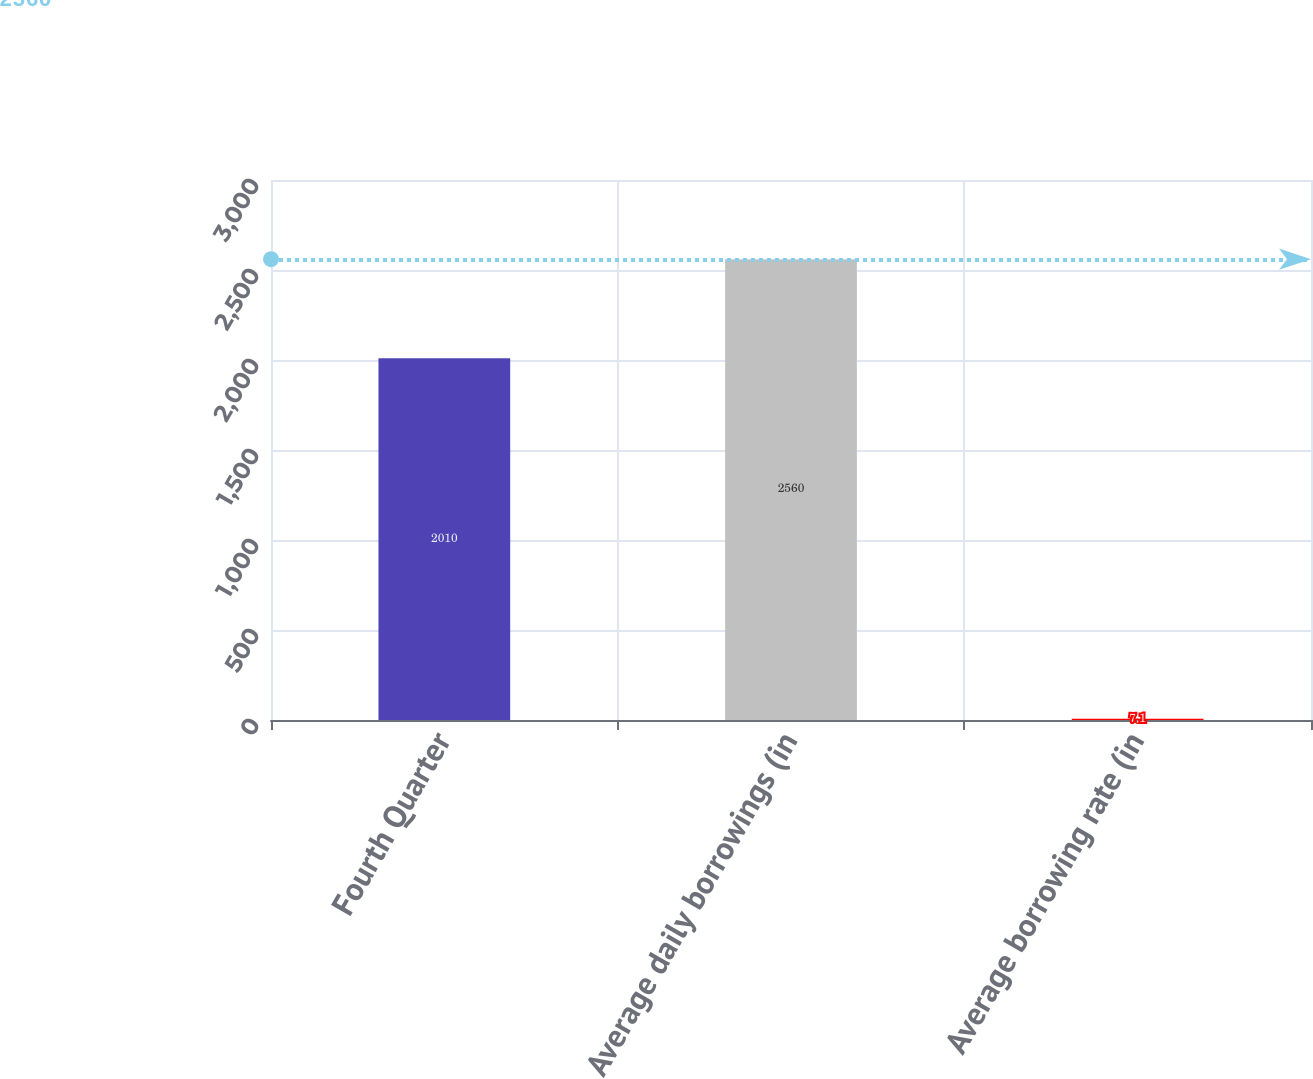<chart> <loc_0><loc_0><loc_500><loc_500><bar_chart><fcel>Fourth Quarter<fcel>Average daily borrowings (in<fcel>Average borrowing rate (in<nl><fcel>2010<fcel>2560<fcel>7.1<nl></chart> 